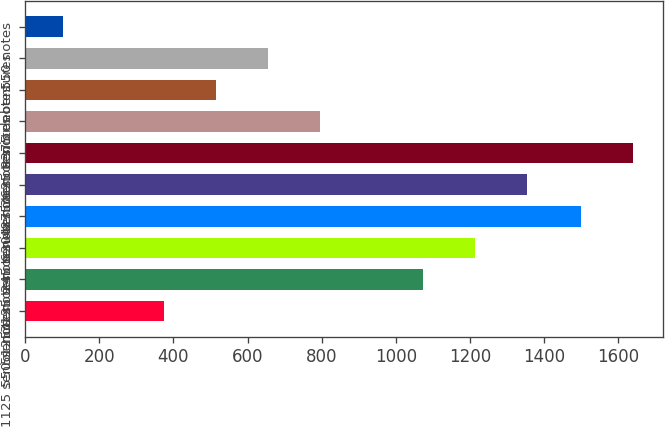Convert chart to OTSL. <chart><loc_0><loc_0><loc_500><loc_500><bar_chart><fcel>1125 senior notes<fcel>550 senior notes<fcel>5125 senior notes<fcel>3125 senior notes<fcel>245 senior notes<fcel>620 senior notes<fcel>4875 senior notes<fcel>3625 senior notes<fcel>8375 debentures<fcel>550 notes<nl><fcel>375<fcel>1073.5<fcel>1213.2<fcel>1500<fcel>1352.9<fcel>1639.7<fcel>794.1<fcel>514.7<fcel>654.4<fcel>103<nl></chart> 